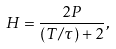Convert formula to latex. <formula><loc_0><loc_0><loc_500><loc_500>H = \frac { 2 P } { ( T / \tau ) + 2 } ,</formula> 